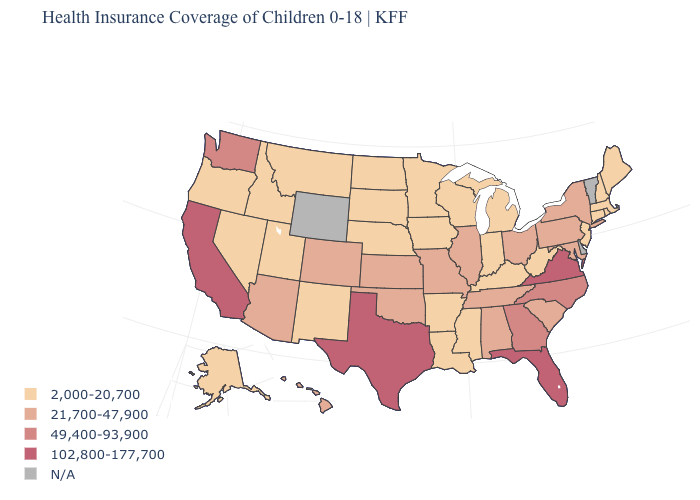Does the map have missing data?
Concise answer only. Yes. What is the lowest value in the USA?
Concise answer only. 2,000-20,700. Name the states that have a value in the range 2,000-20,700?
Write a very short answer. Alaska, Arkansas, Connecticut, Idaho, Indiana, Iowa, Kentucky, Louisiana, Maine, Massachusetts, Michigan, Minnesota, Mississippi, Montana, Nebraska, Nevada, New Hampshire, New Jersey, New Mexico, North Dakota, Oregon, Rhode Island, South Dakota, Utah, West Virginia, Wisconsin. Which states have the highest value in the USA?
Answer briefly. California, Florida, Texas, Virginia. What is the value of West Virginia?
Quick response, please. 2,000-20,700. Name the states that have a value in the range N/A?
Give a very brief answer. Delaware, Vermont, Wyoming. What is the lowest value in states that border Idaho?
Answer briefly. 2,000-20,700. Does Tennessee have the lowest value in the USA?
Concise answer only. No. What is the value of California?
Answer briefly. 102,800-177,700. Name the states that have a value in the range 21,700-47,900?
Write a very short answer. Alabama, Arizona, Colorado, Hawaii, Illinois, Kansas, Maryland, Missouri, New York, Ohio, Oklahoma, Pennsylvania, South Carolina, Tennessee. Which states hav the highest value in the Northeast?
Be succinct. New York, Pennsylvania. Which states hav the highest value in the West?
Answer briefly. California. What is the highest value in the USA?
Keep it brief. 102,800-177,700. Name the states that have a value in the range N/A?
Write a very short answer. Delaware, Vermont, Wyoming. 